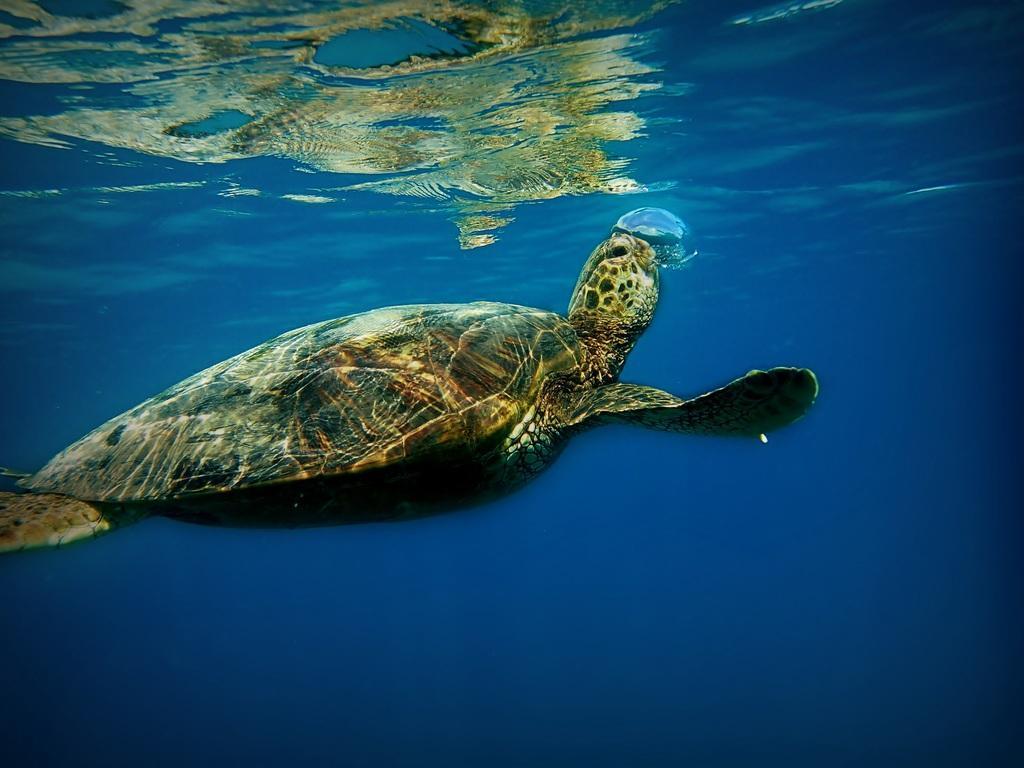Please provide a concise description of this image. In this image I can see the picture of a tortoise which is under the water. I can see the tortoise is black and brown in color and I can see the water are blue in color. 